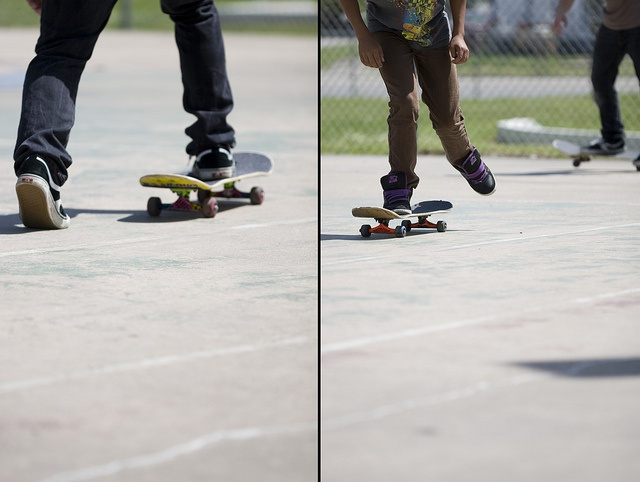Describe the objects in this image and their specific colors. I can see people in olive, black, gray, and darkgray tones, people in olive, black, and gray tones, people in olive, black, gray, and darkgray tones, skateboard in olive, black, lightgray, and darkgray tones, and skateboard in olive, black, lightgray, and gray tones in this image. 